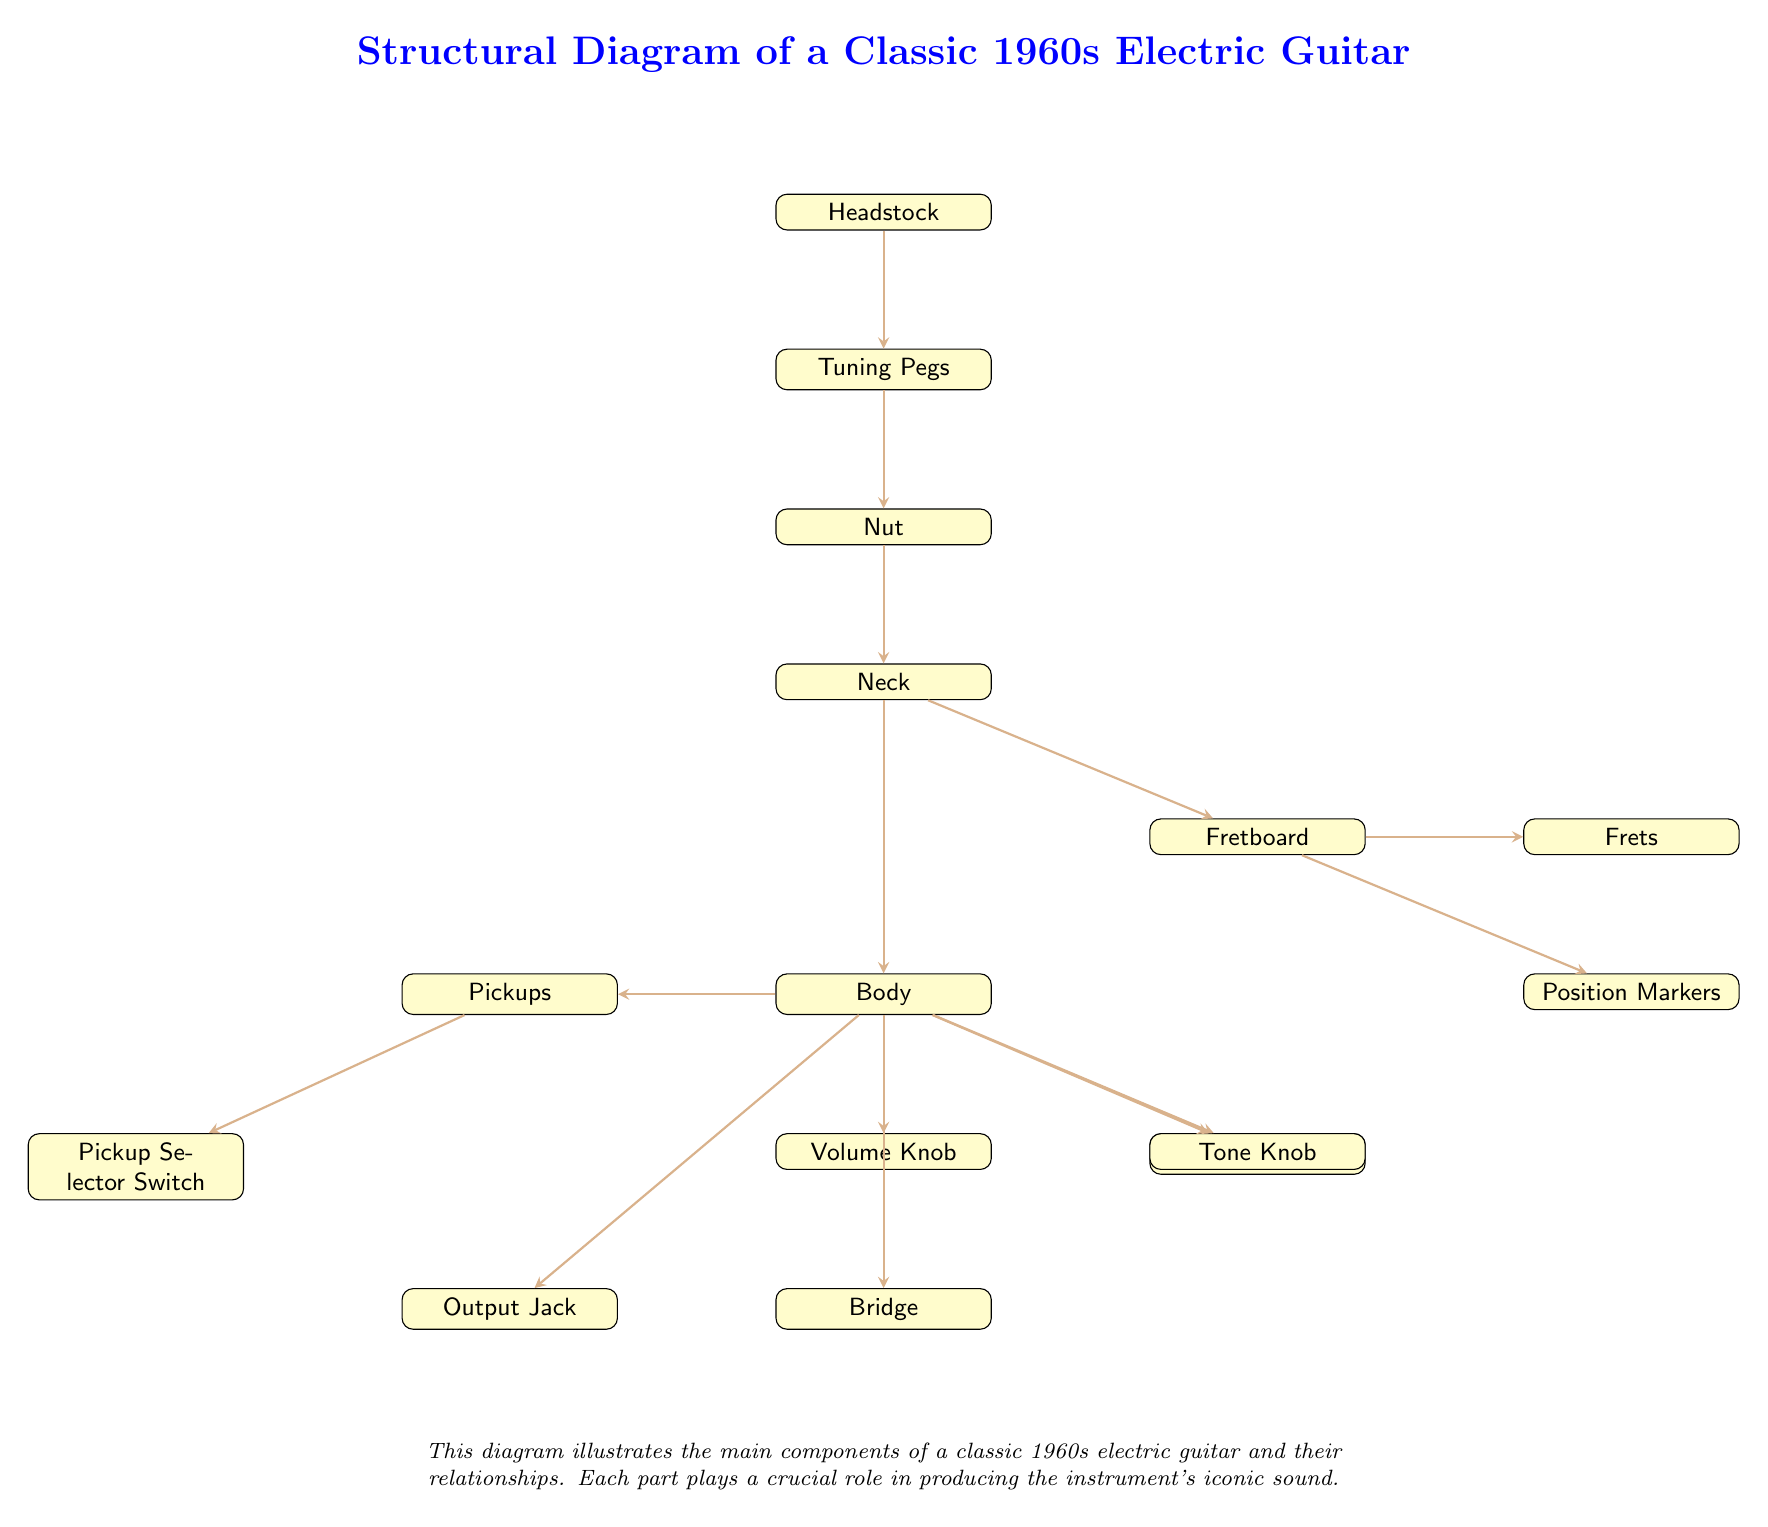What is the lowest component in the diagram? The lowest component is the Output Jack, as it is positioned at the bottom of the diagram.
Answer: Output Jack How many tuning pegs are present in the diagram? The diagram shows one node labeled "Tuning Pegs," indicating a single set of tuning pegs, which typically includes six individual pegs on a guitar.
Answer: Tuning Pegs Which component comes right after the Neck in the flow of connections? After the Neck, the next component in the flow is the Fretboard, as indicated by the directed arrows connecting them.
Answer: Fretboard What is the relationship between the Pickups and the Selector Switch? The relationship is that the Pickups are directly connected to the Pickup Selector Switch, indicating that the Selector Switch controls which pickups are used for sound output.
Answer: Connected Identify one function of the Volume Knob as depicted in the diagram. The Volume Knob's function is to control the overall loudness of the guitar's output sound, as represented in its positioning in the diagram connected to the Body.
Answer: Control loudness How many nodes represent the guitar’s body components? The guitar's body components are represented by three nodes: Body, Pickguard, and Pickups, totaling three distinct nodes.
Answer: Three Which component is directly linked to both the Volume Knob and the Tone Knob? The Body is the component that has direct links to both the Volume Knob and the Tone Knob, indicating it is central to sound control elements.
Answer: Body Explain the flow of sound from the Pickups to the Output Jack. Sound begins at the Pickups, which capture the string vibrations. It flows through the Pickup Selector Switch for selection, then it routes through the Volume Knob and Tone Knob, before finally reaching the Output Jack, where it exits the guitar. This flow illustrates how sound is processed and adjusted before being output.
Answer: Pickups to Output Jack What part is indicated as providing tonal adjustments? The Tone Knob is designated in the diagram as the component that adjusts tonal quality, which is important for shaping the sound of the guitar.
Answer: Tone Knob 